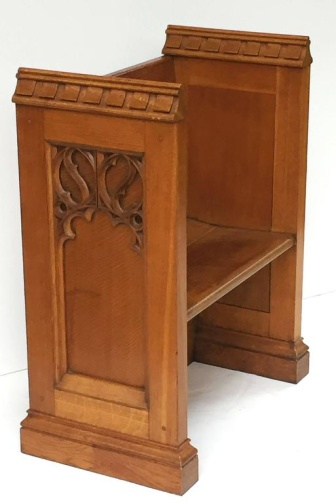What kind of wood do you think this bench is made from? Judging by the light color and grain pattern, this bench is likely made from oak or perhaps maple wood. Both types of wood are known for their durability and beauty, making them popular choices for furniture that needs to last through the ages. The light finish highlights the natural beauty and grain of the wood, suggesting that it was chosen not only for its strength but also for its aesthetic qualities. Create a story around this bench, involving whimsical elements. Once upon a time, in a quaint village nestled in a forgotten valley, there stood a peculiar wooden bench at the heart of the enchanted forest. This was no ordinary bench, for it was crafted from the ancient oak of the Wise Tree, which held the knowledge of centuries in its roots. Legend had it that whoever sat upon this bench could converse with the spirits of the forest, each leaf and branch whispering secrets of old. One bright morning, a curious young girl named Elara stumbled upon the bench while chasing a flock of fireflies. As she sat down to catch her breath, the carvings on the bench began to glow softly, and the air filled with a gentle hum. The Wise Tree had chosen her as the next guardian of the forest, and from that day on, the bench became the meeting place for woodland creatures and mystical beings, all working together to protect the magic that flowed through the valley. What might be the significance of the carvings on this bench in a realistic everyday scenario? In a realistic everyday scenario, the carvings on the bench possibly represent craftsmanship, tradition, and values. The detailed work suggests that it was made by a skilled artisan, possibly passed down through generations. It could belong to a family heritage, a piece that has witnessed many important life events from generations to generations. The bench might serve as a reminder of cultural roots, family stories, and values passed down through the years, symbolizing continuity and legacy in everyday life. 